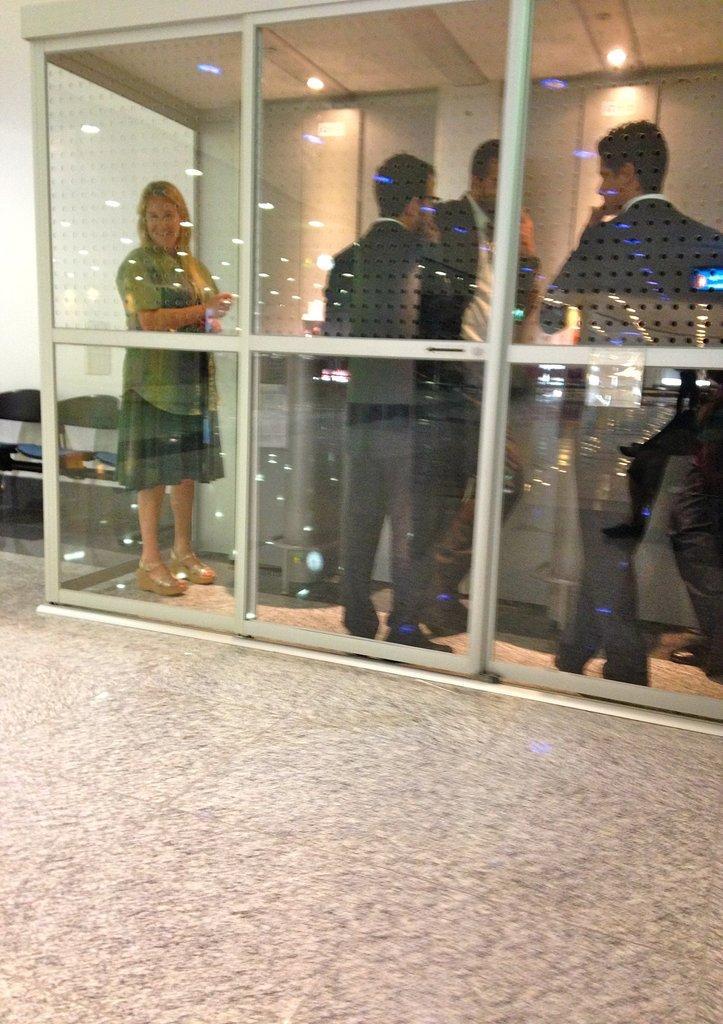Could you give a brief overview of what you see in this image? This image is taken indoors. At the bottom of the image there is a floor. On the left side of the image there are two chairs and there is a wall. In the middle of the image there is a glass door. Through the door we can see there are a few people standing on the floor. At the top of the image there is a roof and there are two lights. 